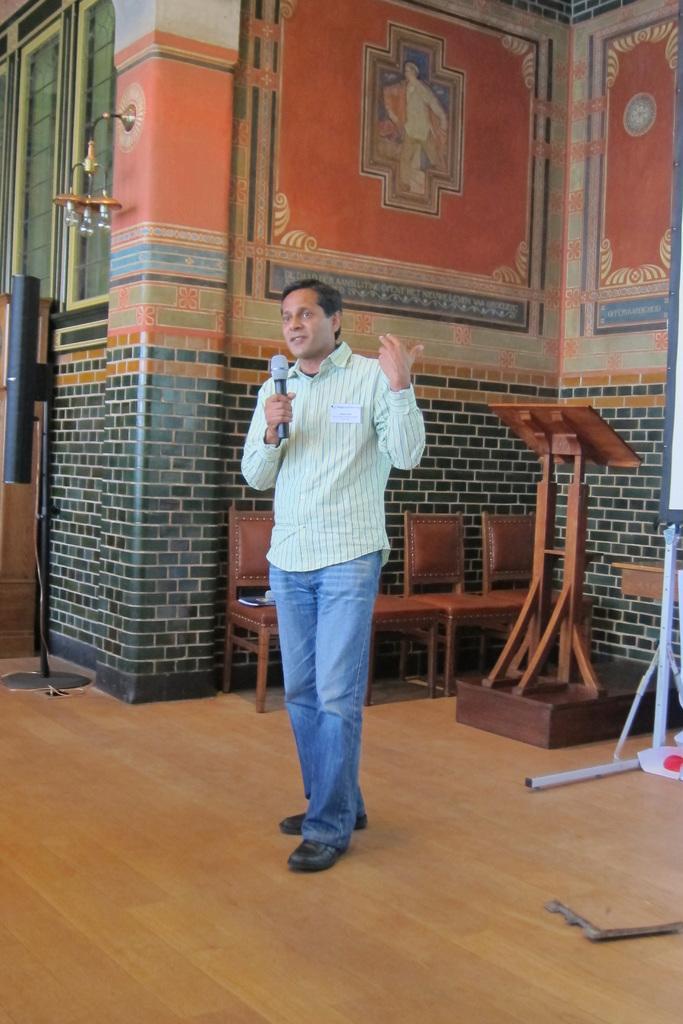Describe this image in one or two sentences. In this image there is a man standing. He is holding a microphone in his hand. Behind him there are chairs and a podium. In the background there is a wall. There are paintings on the wall. To the left there is a wall lap. There is a stand in the image. At the bottom the floor is furnished with the wood. 